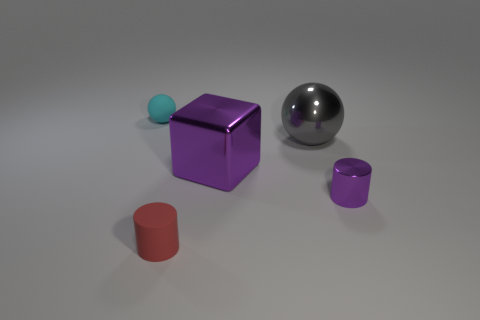Is there anything else that is the same shape as the big purple metal object?
Your answer should be very brief. No. How many big gray rubber objects are there?
Provide a succinct answer. 0. What number of objects are either brown rubber objects or rubber objects?
Ensure brevity in your answer.  2. There is a cylinder that is the same color as the large cube; what size is it?
Provide a succinct answer. Small. Are there any large shiny spheres to the left of the red matte object?
Keep it short and to the point. No. Are there more small red matte things that are behind the tiny rubber cylinder than blocks that are on the right side of the small purple thing?
Your response must be concise. No. There is another object that is the same shape as the cyan rubber thing; what size is it?
Offer a very short reply. Large. What number of balls are either red rubber things or big purple things?
Give a very brief answer. 0. What material is the object that is the same color as the big cube?
Offer a terse response. Metal. Are there fewer cyan spheres to the right of the big block than small shiny cylinders that are in front of the tiny matte cylinder?
Provide a short and direct response. No. 